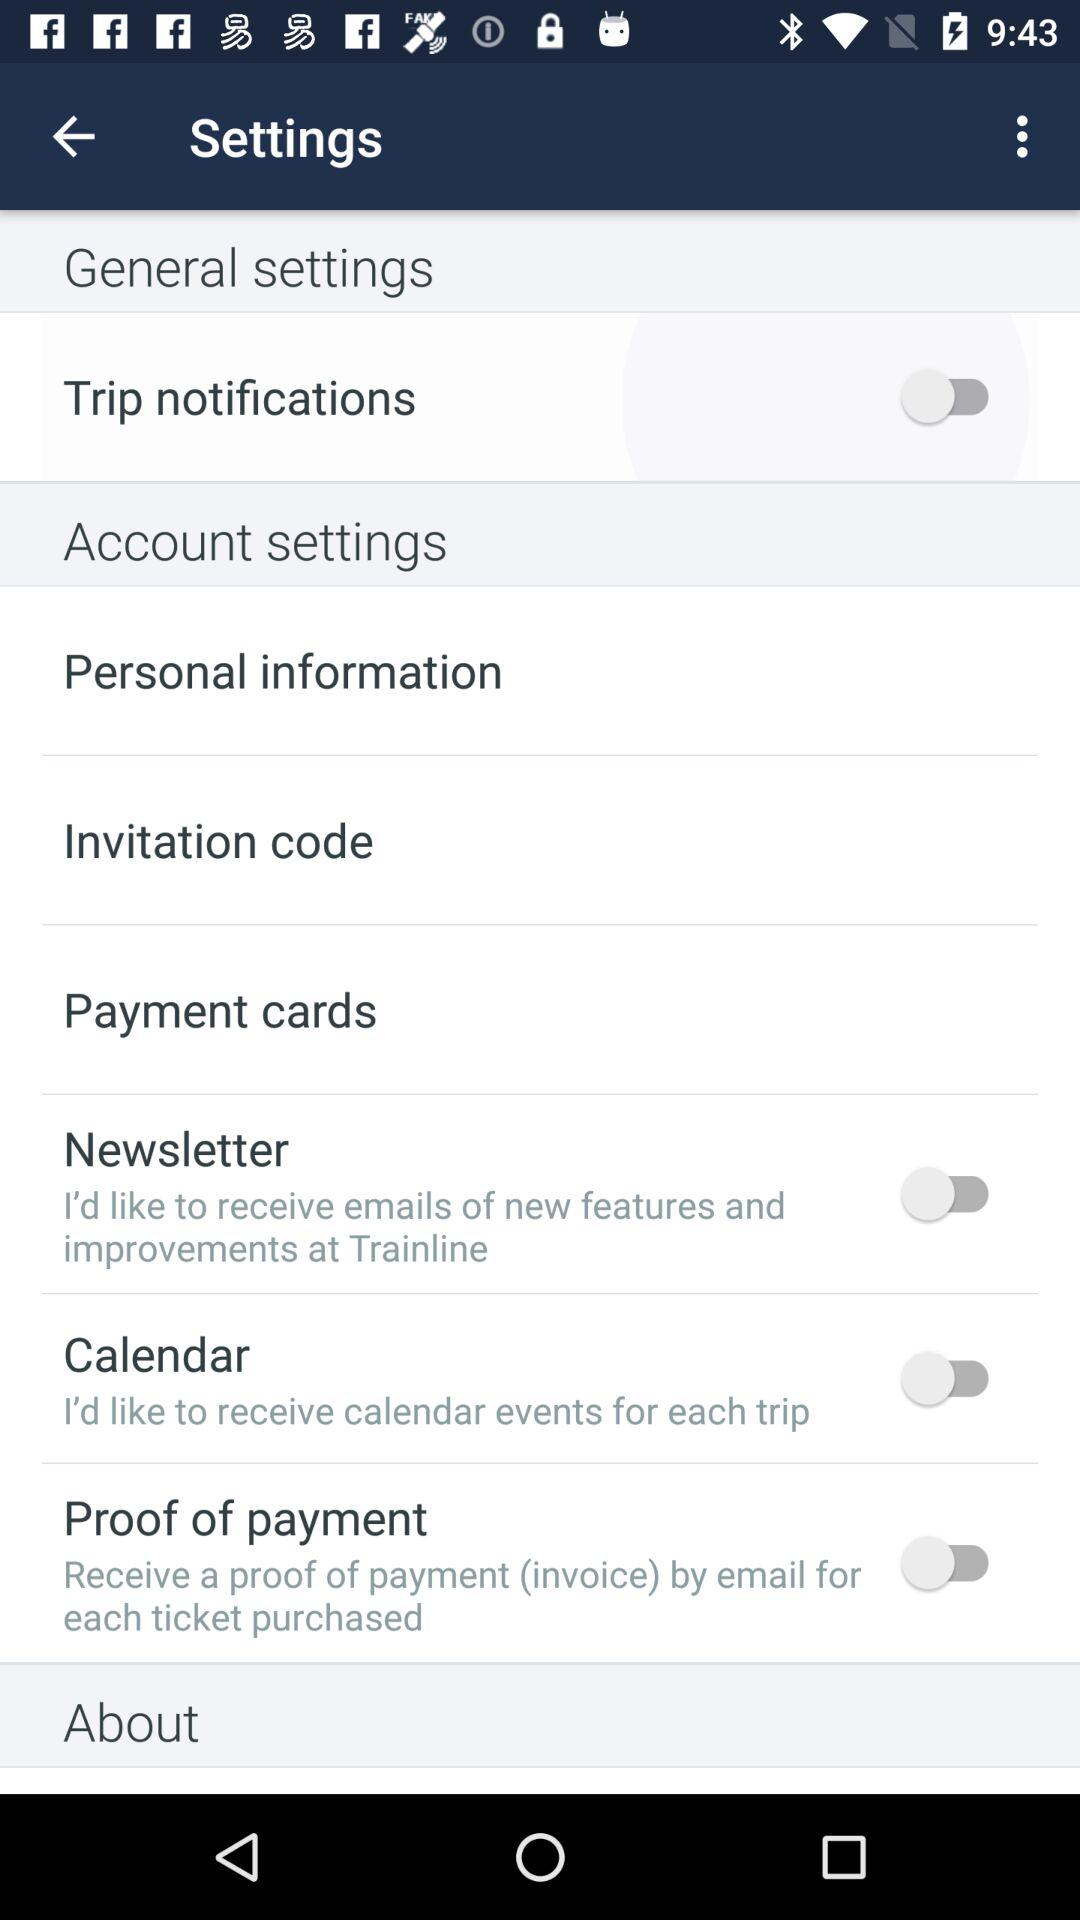What is the status of "Calendar"? The status is "off". 